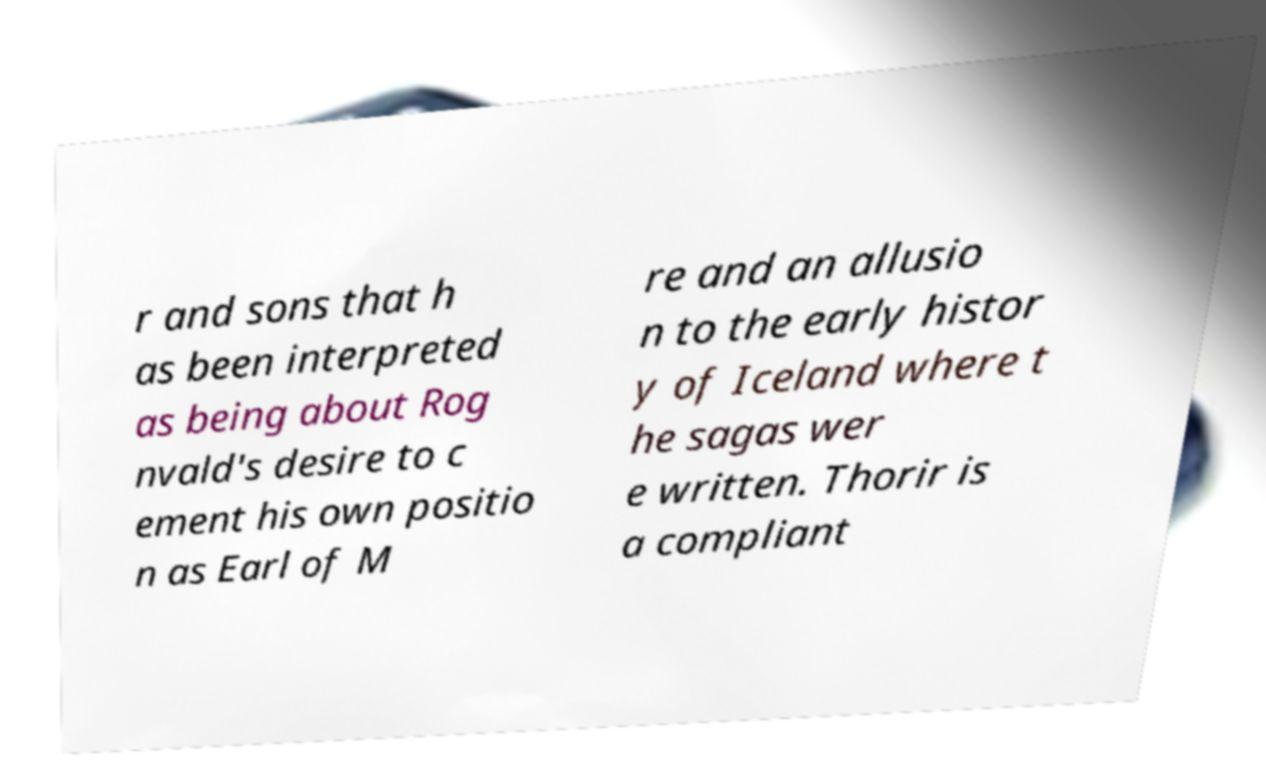Could you extract and type out the text from this image? r and sons that h as been interpreted as being about Rog nvald's desire to c ement his own positio n as Earl of M re and an allusio n to the early histor y of Iceland where t he sagas wer e written. Thorir is a compliant 